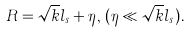<formula> <loc_0><loc_0><loc_500><loc_500>R = \sqrt { k } l _ { s } + \eta , \, ( \eta \ll \sqrt { k } l _ { s } ) .</formula> 